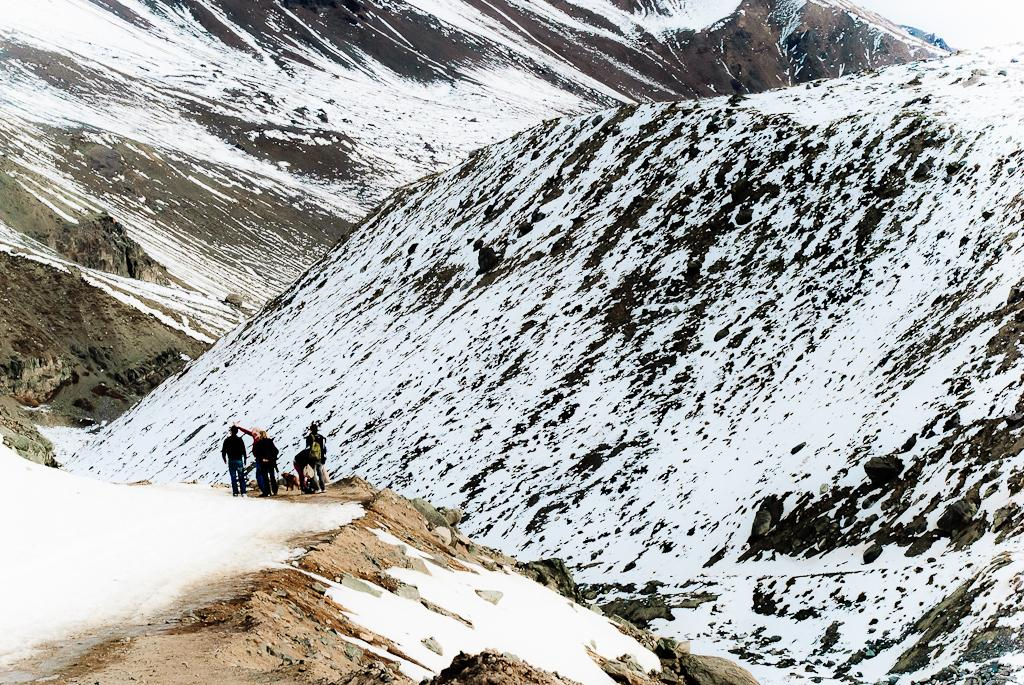What is happening on the road in the image? There are persons on the road in the image. What is the condition of the road? The road has snow on it. What can be seen in the background of the image? There are mountains in the background. How is the weather in the image? The mountains have snow on them, indicating that it is likely cold or snowing. What type of glass is being used by the persons on the road? There is no glass visible in the image; the persons are on a snowy road with mountains in the background. Can you describe the flight of the birds in the image? There are no birds present in the image; it features persons on a snowy road with mountains in the background. 